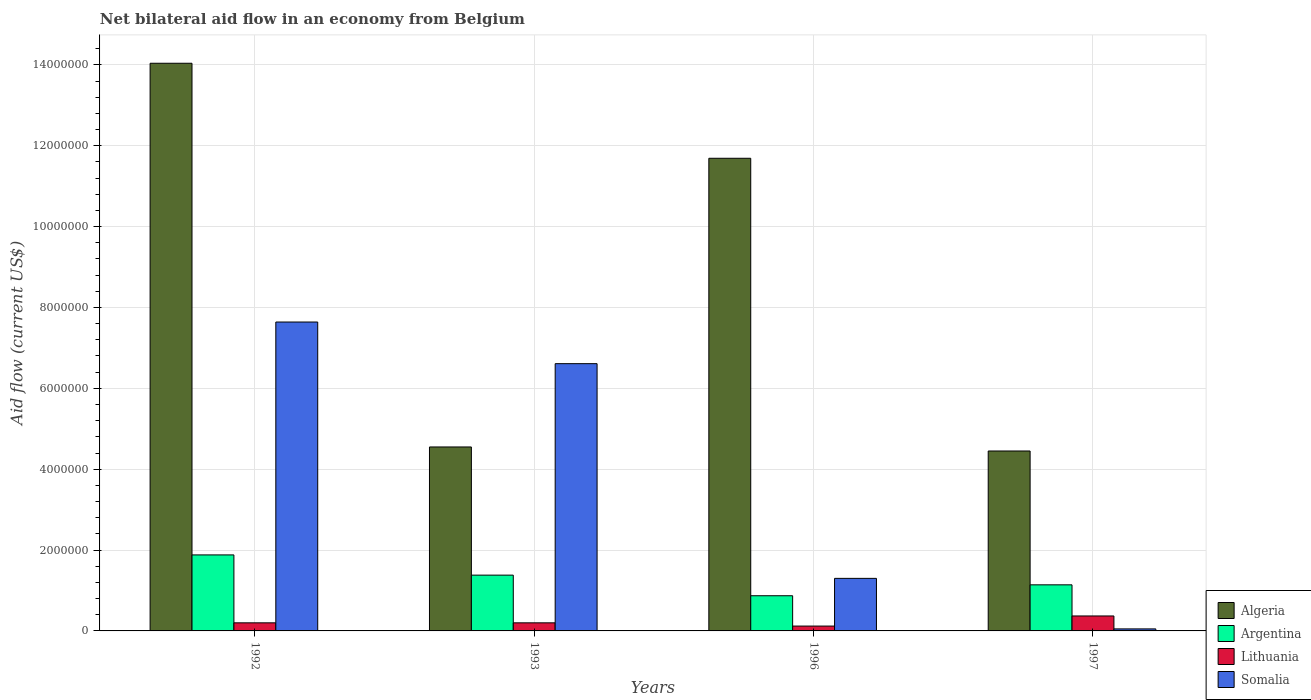How many different coloured bars are there?
Give a very brief answer. 4. Are the number of bars on each tick of the X-axis equal?
Your response must be concise. Yes. How many bars are there on the 2nd tick from the left?
Provide a short and direct response. 4. What is the label of the 4th group of bars from the left?
Offer a terse response. 1997. In how many cases, is the number of bars for a given year not equal to the number of legend labels?
Your answer should be very brief. 0. What is the net bilateral aid flow in Somalia in 1993?
Your answer should be compact. 6.61e+06. Across all years, what is the maximum net bilateral aid flow in Somalia?
Give a very brief answer. 7.64e+06. Across all years, what is the minimum net bilateral aid flow in Argentina?
Offer a terse response. 8.70e+05. In which year was the net bilateral aid flow in Argentina maximum?
Give a very brief answer. 1992. What is the total net bilateral aid flow in Argentina in the graph?
Your answer should be compact. 5.27e+06. What is the difference between the net bilateral aid flow in Somalia in 1992 and the net bilateral aid flow in Argentina in 1993?
Ensure brevity in your answer.  6.26e+06. What is the average net bilateral aid flow in Lithuania per year?
Your response must be concise. 2.22e+05. In the year 1996, what is the difference between the net bilateral aid flow in Somalia and net bilateral aid flow in Lithuania?
Keep it short and to the point. 1.18e+06. In how many years, is the net bilateral aid flow in Lithuania greater than 400000 US$?
Your response must be concise. 0. What is the ratio of the net bilateral aid flow in Lithuania in 1992 to that in 1993?
Provide a succinct answer. 1. Is the net bilateral aid flow in Algeria in 1992 less than that in 1996?
Give a very brief answer. No. Is the difference between the net bilateral aid flow in Somalia in 1993 and 1996 greater than the difference between the net bilateral aid flow in Lithuania in 1993 and 1996?
Give a very brief answer. Yes. What is the difference between the highest and the lowest net bilateral aid flow in Somalia?
Your answer should be compact. 7.59e+06. In how many years, is the net bilateral aid flow in Somalia greater than the average net bilateral aid flow in Somalia taken over all years?
Make the answer very short. 2. Is the sum of the net bilateral aid flow in Argentina in 1992 and 1996 greater than the maximum net bilateral aid flow in Somalia across all years?
Keep it short and to the point. No. What does the 4th bar from the left in 1997 represents?
Provide a succinct answer. Somalia. What does the 1st bar from the right in 1996 represents?
Ensure brevity in your answer.  Somalia. Are all the bars in the graph horizontal?
Provide a succinct answer. No. How many years are there in the graph?
Ensure brevity in your answer.  4. What is the difference between two consecutive major ticks on the Y-axis?
Offer a terse response. 2.00e+06. Does the graph contain any zero values?
Give a very brief answer. No. Does the graph contain grids?
Give a very brief answer. Yes. How many legend labels are there?
Offer a very short reply. 4. What is the title of the graph?
Provide a succinct answer. Net bilateral aid flow in an economy from Belgium. Does "West Bank and Gaza" appear as one of the legend labels in the graph?
Your answer should be very brief. No. What is the label or title of the Y-axis?
Provide a succinct answer. Aid flow (current US$). What is the Aid flow (current US$) of Algeria in 1992?
Your answer should be very brief. 1.40e+07. What is the Aid flow (current US$) of Argentina in 1992?
Your response must be concise. 1.88e+06. What is the Aid flow (current US$) of Lithuania in 1992?
Your answer should be compact. 2.00e+05. What is the Aid flow (current US$) in Somalia in 1992?
Provide a succinct answer. 7.64e+06. What is the Aid flow (current US$) in Algeria in 1993?
Your response must be concise. 4.55e+06. What is the Aid flow (current US$) of Argentina in 1993?
Ensure brevity in your answer.  1.38e+06. What is the Aid flow (current US$) in Somalia in 1993?
Offer a terse response. 6.61e+06. What is the Aid flow (current US$) in Algeria in 1996?
Your answer should be compact. 1.17e+07. What is the Aid flow (current US$) in Argentina in 1996?
Your response must be concise. 8.70e+05. What is the Aid flow (current US$) of Somalia in 1996?
Your response must be concise. 1.30e+06. What is the Aid flow (current US$) in Algeria in 1997?
Give a very brief answer. 4.45e+06. What is the Aid flow (current US$) of Argentina in 1997?
Make the answer very short. 1.14e+06. What is the Aid flow (current US$) of Somalia in 1997?
Provide a short and direct response. 5.00e+04. Across all years, what is the maximum Aid flow (current US$) of Algeria?
Offer a very short reply. 1.40e+07. Across all years, what is the maximum Aid flow (current US$) in Argentina?
Provide a succinct answer. 1.88e+06. Across all years, what is the maximum Aid flow (current US$) of Somalia?
Make the answer very short. 7.64e+06. Across all years, what is the minimum Aid flow (current US$) in Algeria?
Offer a very short reply. 4.45e+06. Across all years, what is the minimum Aid flow (current US$) in Argentina?
Provide a short and direct response. 8.70e+05. Across all years, what is the minimum Aid flow (current US$) of Lithuania?
Your answer should be very brief. 1.20e+05. What is the total Aid flow (current US$) of Algeria in the graph?
Ensure brevity in your answer.  3.47e+07. What is the total Aid flow (current US$) in Argentina in the graph?
Provide a succinct answer. 5.27e+06. What is the total Aid flow (current US$) in Lithuania in the graph?
Provide a succinct answer. 8.90e+05. What is the total Aid flow (current US$) in Somalia in the graph?
Your answer should be compact. 1.56e+07. What is the difference between the Aid flow (current US$) in Algeria in 1992 and that in 1993?
Offer a very short reply. 9.49e+06. What is the difference between the Aid flow (current US$) in Somalia in 1992 and that in 1993?
Offer a terse response. 1.03e+06. What is the difference between the Aid flow (current US$) in Algeria in 1992 and that in 1996?
Give a very brief answer. 2.35e+06. What is the difference between the Aid flow (current US$) in Argentina in 1992 and that in 1996?
Offer a very short reply. 1.01e+06. What is the difference between the Aid flow (current US$) of Lithuania in 1992 and that in 1996?
Ensure brevity in your answer.  8.00e+04. What is the difference between the Aid flow (current US$) in Somalia in 1992 and that in 1996?
Provide a succinct answer. 6.34e+06. What is the difference between the Aid flow (current US$) in Algeria in 1992 and that in 1997?
Make the answer very short. 9.59e+06. What is the difference between the Aid flow (current US$) of Argentina in 1992 and that in 1997?
Make the answer very short. 7.40e+05. What is the difference between the Aid flow (current US$) of Lithuania in 1992 and that in 1997?
Ensure brevity in your answer.  -1.70e+05. What is the difference between the Aid flow (current US$) of Somalia in 1992 and that in 1997?
Provide a short and direct response. 7.59e+06. What is the difference between the Aid flow (current US$) in Algeria in 1993 and that in 1996?
Your answer should be compact. -7.14e+06. What is the difference between the Aid flow (current US$) in Argentina in 1993 and that in 1996?
Ensure brevity in your answer.  5.10e+05. What is the difference between the Aid flow (current US$) of Somalia in 1993 and that in 1996?
Your answer should be compact. 5.31e+06. What is the difference between the Aid flow (current US$) in Algeria in 1993 and that in 1997?
Offer a terse response. 1.00e+05. What is the difference between the Aid flow (current US$) of Argentina in 1993 and that in 1997?
Make the answer very short. 2.40e+05. What is the difference between the Aid flow (current US$) in Lithuania in 1993 and that in 1997?
Provide a short and direct response. -1.70e+05. What is the difference between the Aid flow (current US$) in Somalia in 1993 and that in 1997?
Your answer should be very brief. 6.56e+06. What is the difference between the Aid flow (current US$) of Algeria in 1996 and that in 1997?
Keep it short and to the point. 7.24e+06. What is the difference between the Aid flow (current US$) of Somalia in 1996 and that in 1997?
Ensure brevity in your answer.  1.25e+06. What is the difference between the Aid flow (current US$) of Algeria in 1992 and the Aid flow (current US$) of Argentina in 1993?
Your answer should be very brief. 1.27e+07. What is the difference between the Aid flow (current US$) in Algeria in 1992 and the Aid flow (current US$) in Lithuania in 1993?
Make the answer very short. 1.38e+07. What is the difference between the Aid flow (current US$) of Algeria in 1992 and the Aid flow (current US$) of Somalia in 1993?
Provide a short and direct response. 7.43e+06. What is the difference between the Aid flow (current US$) of Argentina in 1992 and the Aid flow (current US$) of Lithuania in 1993?
Make the answer very short. 1.68e+06. What is the difference between the Aid flow (current US$) of Argentina in 1992 and the Aid flow (current US$) of Somalia in 1993?
Keep it short and to the point. -4.73e+06. What is the difference between the Aid flow (current US$) of Lithuania in 1992 and the Aid flow (current US$) of Somalia in 1993?
Offer a terse response. -6.41e+06. What is the difference between the Aid flow (current US$) in Algeria in 1992 and the Aid flow (current US$) in Argentina in 1996?
Your response must be concise. 1.32e+07. What is the difference between the Aid flow (current US$) of Algeria in 1992 and the Aid flow (current US$) of Lithuania in 1996?
Provide a succinct answer. 1.39e+07. What is the difference between the Aid flow (current US$) in Algeria in 1992 and the Aid flow (current US$) in Somalia in 1996?
Keep it short and to the point. 1.27e+07. What is the difference between the Aid flow (current US$) in Argentina in 1992 and the Aid flow (current US$) in Lithuania in 1996?
Offer a very short reply. 1.76e+06. What is the difference between the Aid flow (current US$) of Argentina in 1992 and the Aid flow (current US$) of Somalia in 1996?
Your response must be concise. 5.80e+05. What is the difference between the Aid flow (current US$) of Lithuania in 1992 and the Aid flow (current US$) of Somalia in 1996?
Give a very brief answer. -1.10e+06. What is the difference between the Aid flow (current US$) in Algeria in 1992 and the Aid flow (current US$) in Argentina in 1997?
Keep it short and to the point. 1.29e+07. What is the difference between the Aid flow (current US$) of Algeria in 1992 and the Aid flow (current US$) of Lithuania in 1997?
Offer a terse response. 1.37e+07. What is the difference between the Aid flow (current US$) of Algeria in 1992 and the Aid flow (current US$) of Somalia in 1997?
Make the answer very short. 1.40e+07. What is the difference between the Aid flow (current US$) of Argentina in 1992 and the Aid flow (current US$) of Lithuania in 1997?
Keep it short and to the point. 1.51e+06. What is the difference between the Aid flow (current US$) of Argentina in 1992 and the Aid flow (current US$) of Somalia in 1997?
Your response must be concise. 1.83e+06. What is the difference between the Aid flow (current US$) in Algeria in 1993 and the Aid flow (current US$) in Argentina in 1996?
Keep it short and to the point. 3.68e+06. What is the difference between the Aid flow (current US$) in Algeria in 1993 and the Aid flow (current US$) in Lithuania in 1996?
Offer a very short reply. 4.43e+06. What is the difference between the Aid flow (current US$) in Algeria in 1993 and the Aid flow (current US$) in Somalia in 1996?
Offer a terse response. 3.25e+06. What is the difference between the Aid flow (current US$) of Argentina in 1993 and the Aid flow (current US$) of Lithuania in 1996?
Provide a short and direct response. 1.26e+06. What is the difference between the Aid flow (current US$) in Argentina in 1993 and the Aid flow (current US$) in Somalia in 1996?
Make the answer very short. 8.00e+04. What is the difference between the Aid flow (current US$) in Lithuania in 1993 and the Aid flow (current US$) in Somalia in 1996?
Ensure brevity in your answer.  -1.10e+06. What is the difference between the Aid flow (current US$) of Algeria in 1993 and the Aid flow (current US$) of Argentina in 1997?
Make the answer very short. 3.41e+06. What is the difference between the Aid flow (current US$) in Algeria in 1993 and the Aid flow (current US$) in Lithuania in 1997?
Your answer should be compact. 4.18e+06. What is the difference between the Aid flow (current US$) of Algeria in 1993 and the Aid flow (current US$) of Somalia in 1997?
Your response must be concise. 4.50e+06. What is the difference between the Aid flow (current US$) of Argentina in 1993 and the Aid flow (current US$) of Lithuania in 1997?
Keep it short and to the point. 1.01e+06. What is the difference between the Aid flow (current US$) of Argentina in 1993 and the Aid flow (current US$) of Somalia in 1997?
Your answer should be compact. 1.33e+06. What is the difference between the Aid flow (current US$) of Lithuania in 1993 and the Aid flow (current US$) of Somalia in 1997?
Keep it short and to the point. 1.50e+05. What is the difference between the Aid flow (current US$) in Algeria in 1996 and the Aid flow (current US$) in Argentina in 1997?
Your answer should be very brief. 1.06e+07. What is the difference between the Aid flow (current US$) of Algeria in 1996 and the Aid flow (current US$) of Lithuania in 1997?
Provide a succinct answer. 1.13e+07. What is the difference between the Aid flow (current US$) in Algeria in 1996 and the Aid flow (current US$) in Somalia in 1997?
Offer a terse response. 1.16e+07. What is the difference between the Aid flow (current US$) in Argentina in 1996 and the Aid flow (current US$) in Somalia in 1997?
Offer a very short reply. 8.20e+05. What is the difference between the Aid flow (current US$) in Lithuania in 1996 and the Aid flow (current US$) in Somalia in 1997?
Ensure brevity in your answer.  7.00e+04. What is the average Aid flow (current US$) in Algeria per year?
Provide a succinct answer. 8.68e+06. What is the average Aid flow (current US$) in Argentina per year?
Your response must be concise. 1.32e+06. What is the average Aid flow (current US$) in Lithuania per year?
Keep it short and to the point. 2.22e+05. What is the average Aid flow (current US$) of Somalia per year?
Offer a terse response. 3.90e+06. In the year 1992, what is the difference between the Aid flow (current US$) of Algeria and Aid flow (current US$) of Argentina?
Your answer should be compact. 1.22e+07. In the year 1992, what is the difference between the Aid flow (current US$) of Algeria and Aid flow (current US$) of Lithuania?
Your answer should be compact. 1.38e+07. In the year 1992, what is the difference between the Aid flow (current US$) of Algeria and Aid flow (current US$) of Somalia?
Keep it short and to the point. 6.40e+06. In the year 1992, what is the difference between the Aid flow (current US$) of Argentina and Aid flow (current US$) of Lithuania?
Ensure brevity in your answer.  1.68e+06. In the year 1992, what is the difference between the Aid flow (current US$) in Argentina and Aid flow (current US$) in Somalia?
Provide a short and direct response. -5.76e+06. In the year 1992, what is the difference between the Aid flow (current US$) in Lithuania and Aid flow (current US$) in Somalia?
Your answer should be very brief. -7.44e+06. In the year 1993, what is the difference between the Aid flow (current US$) in Algeria and Aid flow (current US$) in Argentina?
Provide a short and direct response. 3.17e+06. In the year 1993, what is the difference between the Aid flow (current US$) of Algeria and Aid flow (current US$) of Lithuania?
Give a very brief answer. 4.35e+06. In the year 1993, what is the difference between the Aid flow (current US$) of Algeria and Aid flow (current US$) of Somalia?
Offer a very short reply. -2.06e+06. In the year 1993, what is the difference between the Aid flow (current US$) of Argentina and Aid flow (current US$) of Lithuania?
Offer a terse response. 1.18e+06. In the year 1993, what is the difference between the Aid flow (current US$) of Argentina and Aid flow (current US$) of Somalia?
Make the answer very short. -5.23e+06. In the year 1993, what is the difference between the Aid flow (current US$) in Lithuania and Aid flow (current US$) in Somalia?
Your answer should be very brief. -6.41e+06. In the year 1996, what is the difference between the Aid flow (current US$) in Algeria and Aid flow (current US$) in Argentina?
Your response must be concise. 1.08e+07. In the year 1996, what is the difference between the Aid flow (current US$) in Algeria and Aid flow (current US$) in Lithuania?
Your response must be concise. 1.16e+07. In the year 1996, what is the difference between the Aid flow (current US$) in Algeria and Aid flow (current US$) in Somalia?
Provide a short and direct response. 1.04e+07. In the year 1996, what is the difference between the Aid flow (current US$) in Argentina and Aid flow (current US$) in Lithuania?
Make the answer very short. 7.50e+05. In the year 1996, what is the difference between the Aid flow (current US$) of Argentina and Aid flow (current US$) of Somalia?
Provide a succinct answer. -4.30e+05. In the year 1996, what is the difference between the Aid flow (current US$) in Lithuania and Aid flow (current US$) in Somalia?
Ensure brevity in your answer.  -1.18e+06. In the year 1997, what is the difference between the Aid flow (current US$) in Algeria and Aid flow (current US$) in Argentina?
Provide a short and direct response. 3.31e+06. In the year 1997, what is the difference between the Aid flow (current US$) of Algeria and Aid flow (current US$) of Lithuania?
Your answer should be compact. 4.08e+06. In the year 1997, what is the difference between the Aid flow (current US$) of Algeria and Aid flow (current US$) of Somalia?
Provide a short and direct response. 4.40e+06. In the year 1997, what is the difference between the Aid flow (current US$) in Argentina and Aid flow (current US$) in Lithuania?
Offer a terse response. 7.70e+05. In the year 1997, what is the difference between the Aid flow (current US$) in Argentina and Aid flow (current US$) in Somalia?
Offer a terse response. 1.09e+06. In the year 1997, what is the difference between the Aid flow (current US$) of Lithuania and Aid flow (current US$) of Somalia?
Offer a terse response. 3.20e+05. What is the ratio of the Aid flow (current US$) in Algeria in 1992 to that in 1993?
Your answer should be compact. 3.09. What is the ratio of the Aid flow (current US$) of Argentina in 1992 to that in 1993?
Offer a terse response. 1.36. What is the ratio of the Aid flow (current US$) in Somalia in 1992 to that in 1993?
Your response must be concise. 1.16. What is the ratio of the Aid flow (current US$) in Algeria in 1992 to that in 1996?
Keep it short and to the point. 1.2. What is the ratio of the Aid flow (current US$) in Argentina in 1992 to that in 1996?
Your answer should be very brief. 2.16. What is the ratio of the Aid flow (current US$) in Lithuania in 1992 to that in 1996?
Give a very brief answer. 1.67. What is the ratio of the Aid flow (current US$) in Somalia in 1992 to that in 1996?
Your response must be concise. 5.88. What is the ratio of the Aid flow (current US$) in Algeria in 1992 to that in 1997?
Offer a very short reply. 3.16. What is the ratio of the Aid flow (current US$) in Argentina in 1992 to that in 1997?
Your answer should be compact. 1.65. What is the ratio of the Aid flow (current US$) of Lithuania in 1992 to that in 1997?
Your response must be concise. 0.54. What is the ratio of the Aid flow (current US$) of Somalia in 1992 to that in 1997?
Ensure brevity in your answer.  152.8. What is the ratio of the Aid flow (current US$) of Algeria in 1993 to that in 1996?
Your response must be concise. 0.39. What is the ratio of the Aid flow (current US$) of Argentina in 1993 to that in 1996?
Your answer should be compact. 1.59. What is the ratio of the Aid flow (current US$) in Lithuania in 1993 to that in 1996?
Ensure brevity in your answer.  1.67. What is the ratio of the Aid flow (current US$) of Somalia in 1993 to that in 1996?
Your answer should be very brief. 5.08. What is the ratio of the Aid flow (current US$) of Algeria in 1993 to that in 1997?
Provide a succinct answer. 1.02. What is the ratio of the Aid flow (current US$) of Argentina in 1993 to that in 1997?
Give a very brief answer. 1.21. What is the ratio of the Aid flow (current US$) in Lithuania in 1993 to that in 1997?
Your answer should be very brief. 0.54. What is the ratio of the Aid flow (current US$) of Somalia in 1993 to that in 1997?
Your answer should be very brief. 132.2. What is the ratio of the Aid flow (current US$) in Algeria in 1996 to that in 1997?
Make the answer very short. 2.63. What is the ratio of the Aid flow (current US$) in Argentina in 1996 to that in 1997?
Make the answer very short. 0.76. What is the ratio of the Aid flow (current US$) of Lithuania in 1996 to that in 1997?
Ensure brevity in your answer.  0.32. What is the ratio of the Aid flow (current US$) in Somalia in 1996 to that in 1997?
Your answer should be very brief. 26. What is the difference between the highest and the second highest Aid flow (current US$) of Algeria?
Offer a terse response. 2.35e+06. What is the difference between the highest and the second highest Aid flow (current US$) of Argentina?
Offer a very short reply. 5.00e+05. What is the difference between the highest and the second highest Aid flow (current US$) of Somalia?
Give a very brief answer. 1.03e+06. What is the difference between the highest and the lowest Aid flow (current US$) of Algeria?
Make the answer very short. 9.59e+06. What is the difference between the highest and the lowest Aid flow (current US$) of Argentina?
Offer a very short reply. 1.01e+06. What is the difference between the highest and the lowest Aid flow (current US$) of Lithuania?
Offer a terse response. 2.50e+05. What is the difference between the highest and the lowest Aid flow (current US$) of Somalia?
Keep it short and to the point. 7.59e+06. 